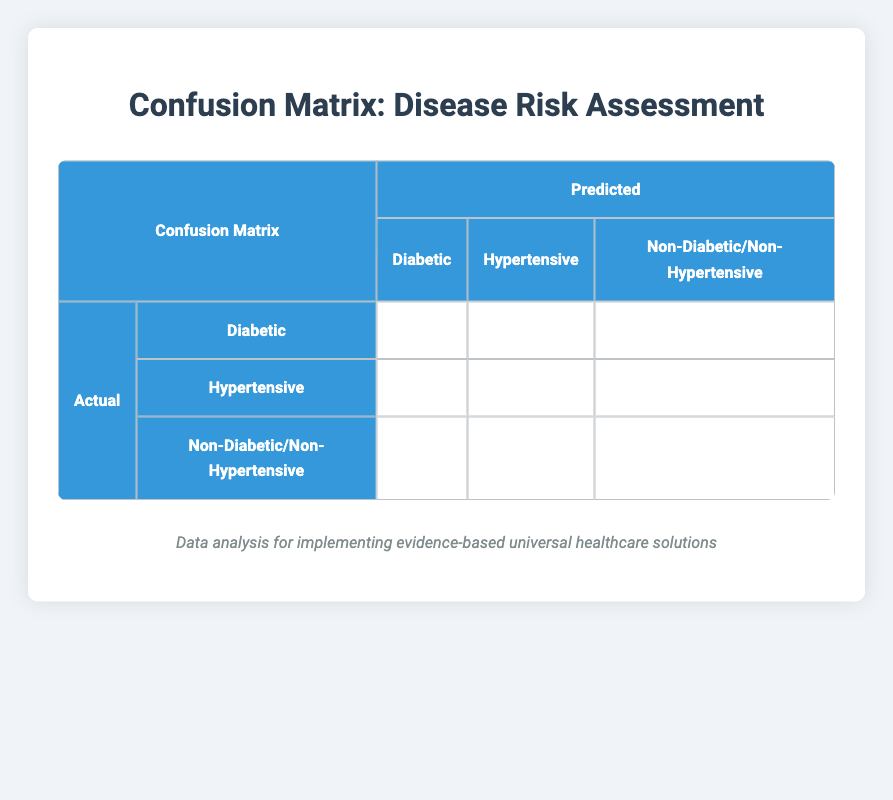What is the number of true positives for the Diabetic category? The table shows that the true positives for the Diabetic category are represented in the corresponding cell under the Diabetic actual status and Diabetic predicted status. The value is 2.
Answer: 2 What is the total number of patients predicted to be Non-Diabetic/Non-Hypertensive? By looking at the row where the actual status is Non-Diabetic/Non-Hypertensive, we can see that the predicted status shows a value of 3 in the true negative cell. This value represents the total number of patients predicted to be Non-Diabetic/Non-Hypertensive, which is 3.
Answer: 3 How many patients were misclassified as Diabetic when they were actually Non-Diabetic? The table shows that there is 1 patient predicted as Diabetic when the actual status is Non-Diabetic, indicated in the false positive column in the Non-Diabetic row.
Answer: 1 Is there any patient who is actually Hypertensive but was predicted as Diabetic? Looking at the confusion matrix for the Hypertensive actual category, we can see that there are no patients predicted as Diabetic, which means the answer is false.
Answer: No What is the percentage of patients accurately diagnosed as Hypertensive? To find the accuracy for the Hypertensive diagnosis, we take the true positives (2) and divide by the total actual Hypertensive cases (2 true positives and 1 false negative, totaling 3). Thus, the accuracy is (2/3) * 100 = 66.67%.
Answer: 66.67% What is the sum of false negatives across all disease categories? By examining each category’s false negatives: for Diabetic (1), Hypertensive (1), and Non-Diabetic/Non-Hypertensive (0), the total sum will be 1 + 1 + 0 = 2.
Answer: 2 How many patients were correctly diagnosed across all categories? The total correct diagnoses are found by summing all the true positives (2 for Diabetic, 2 for Hypertensive, and 3 for Non-Diabetic/Non-Hypertensive). This gives 2 + 2 + 3 = 7.
Answer: 7 What was the total number of actual Diabetic patients? The actual Diabetic patients can be summed across the table, which shows 2 true positives and 1 false negative (2 + 0 + 1 = 3), indicating that there were 3 actual Diabetic patients.
Answer: 3 Are there more patients correctly classified as Non-Diabetic/Non-Hypertensive compared to those classified as Diabetic? The confusion matrix shows that 3 patients were correctly classified as Non-Diabetic/Non-Hypertensive compared to only 2 as Diabetic. Thus, this statement is true.
Answer: Yes 